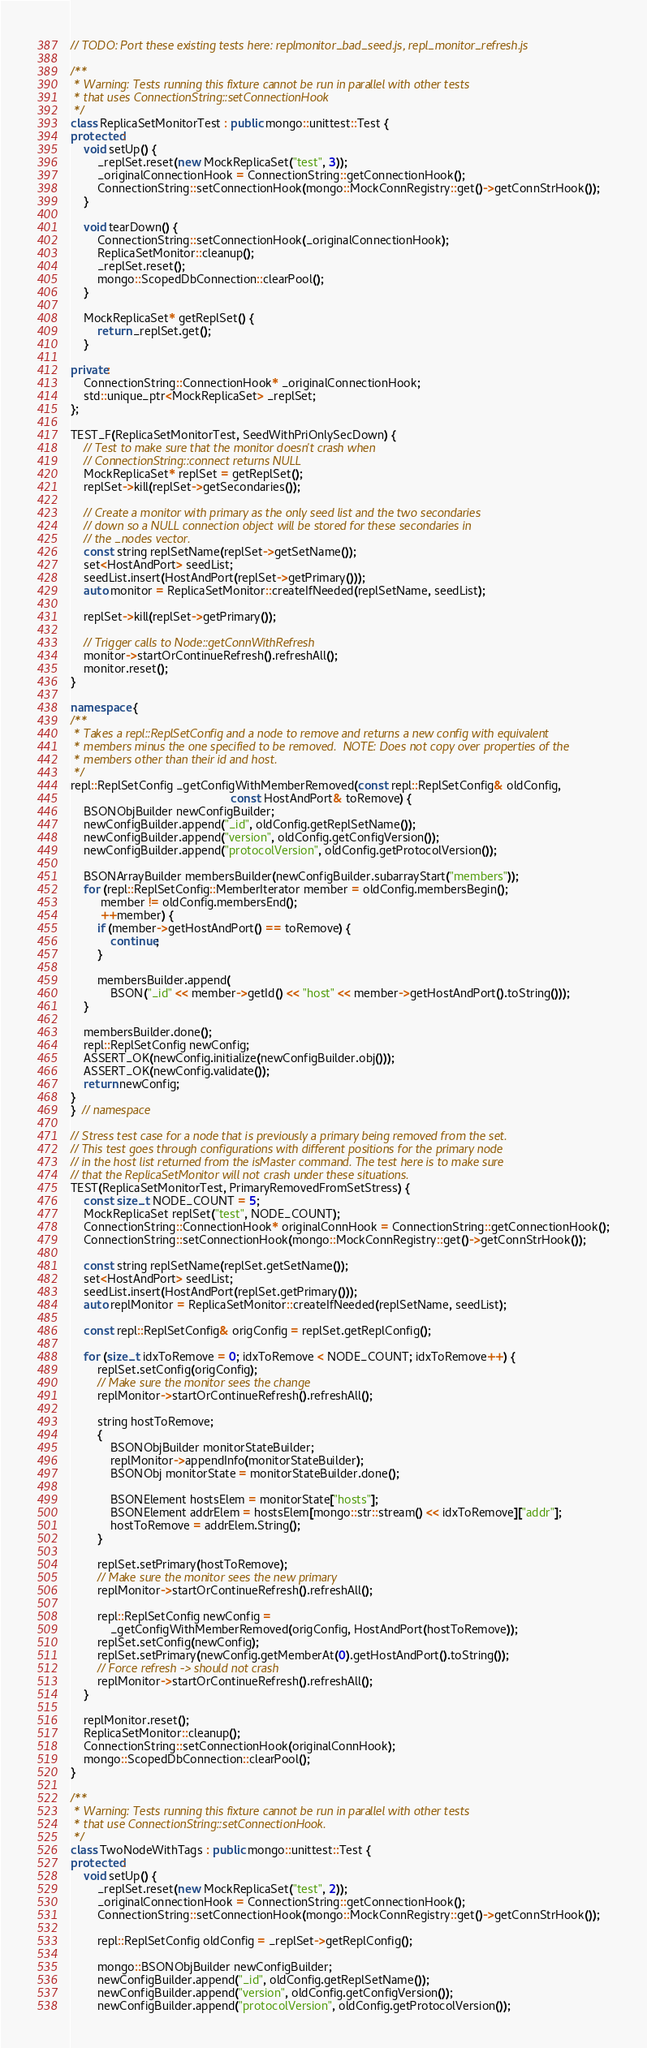<code> <loc_0><loc_0><loc_500><loc_500><_C++_>// TODO: Port these existing tests here: replmonitor_bad_seed.js, repl_monitor_refresh.js

/**
 * Warning: Tests running this fixture cannot be run in parallel with other tests
 * that uses ConnectionString::setConnectionHook
 */
class ReplicaSetMonitorTest : public mongo::unittest::Test {
protected:
    void setUp() {
        _replSet.reset(new MockReplicaSet("test", 3));
        _originalConnectionHook = ConnectionString::getConnectionHook();
        ConnectionString::setConnectionHook(mongo::MockConnRegistry::get()->getConnStrHook());
    }

    void tearDown() {
        ConnectionString::setConnectionHook(_originalConnectionHook);
        ReplicaSetMonitor::cleanup();
        _replSet.reset();
        mongo::ScopedDbConnection::clearPool();
    }

    MockReplicaSet* getReplSet() {
        return _replSet.get();
    }

private:
    ConnectionString::ConnectionHook* _originalConnectionHook;
    std::unique_ptr<MockReplicaSet> _replSet;
};

TEST_F(ReplicaSetMonitorTest, SeedWithPriOnlySecDown) {
    // Test to make sure that the monitor doesn't crash when
    // ConnectionString::connect returns NULL
    MockReplicaSet* replSet = getReplSet();
    replSet->kill(replSet->getSecondaries());

    // Create a monitor with primary as the only seed list and the two secondaries
    // down so a NULL connection object will be stored for these secondaries in
    // the _nodes vector.
    const string replSetName(replSet->getSetName());
    set<HostAndPort> seedList;
    seedList.insert(HostAndPort(replSet->getPrimary()));
    auto monitor = ReplicaSetMonitor::createIfNeeded(replSetName, seedList);

    replSet->kill(replSet->getPrimary());

    // Trigger calls to Node::getConnWithRefresh
    monitor->startOrContinueRefresh().refreshAll();
    monitor.reset();
}

namespace {
/**
 * Takes a repl::ReplSetConfig and a node to remove and returns a new config with equivalent
 * members minus the one specified to be removed.  NOTE: Does not copy over properties of the
 * members other than their id and host.
 */
repl::ReplSetConfig _getConfigWithMemberRemoved(const repl::ReplSetConfig& oldConfig,
                                                const HostAndPort& toRemove) {
    BSONObjBuilder newConfigBuilder;
    newConfigBuilder.append("_id", oldConfig.getReplSetName());
    newConfigBuilder.append("version", oldConfig.getConfigVersion());
    newConfigBuilder.append("protocolVersion", oldConfig.getProtocolVersion());

    BSONArrayBuilder membersBuilder(newConfigBuilder.subarrayStart("members"));
    for (repl::ReplSetConfig::MemberIterator member = oldConfig.membersBegin();
         member != oldConfig.membersEnd();
         ++member) {
        if (member->getHostAndPort() == toRemove) {
            continue;
        }

        membersBuilder.append(
            BSON("_id" << member->getId() << "host" << member->getHostAndPort().toString()));
    }

    membersBuilder.done();
    repl::ReplSetConfig newConfig;
    ASSERT_OK(newConfig.initialize(newConfigBuilder.obj()));
    ASSERT_OK(newConfig.validate());
    return newConfig;
}
}  // namespace

// Stress test case for a node that is previously a primary being removed from the set.
// This test goes through configurations with different positions for the primary node
// in the host list returned from the isMaster command. The test here is to make sure
// that the ReplicaSetMonitor will not crash under these situations.
TEST(ReplicaSetMonitorTest, PrimaryRemovedFromSetStress) {
    const size_t NODE_COUNT = 5;
    MockReplicaSet replSet("test", NODE_COUNT);
    ConnectionString::ConnectionHook* originalConnHook = ConnectionString::getConnectionHook();
    ConnectionString::setConnectionHook(mongo::MockConnRegistry::get()->getConnStrHook());

    const string replSetName(replSet.getSetName());
    set<HostAndPort> seedList;
    seedList.insert(HostAndPort(replSet.getPrimary()));
    auto replMonitor = ReplicaSetMonitor::createIfNeeded(replSetName, seedList);

    const repl::ReplSetConfig& origConfig = replSet.getReplConfig();

    for (size_t idxToRemove = 0; idxToRemove < NODE_COUNT; idxToRemove++) {
        replSet.setConfig(origConfig);
        // Make sure the monitor sees the change
        replMonitor->startOrContinueRefresh().refreshAll();

        string hostToRemove;
        {
            BSONObjBuilder monitorStateBuilder;
            replMonitor->appendInfo(monitorStateBuilder);
            BSONObj monitorState = monitorStateBuilder.done();

            BSONElement hostsElem = monitorState["hosts"];
            BSONElement addrElem = hostsElem[mongo::str::stream() << idxToRemove]["addr"];
            hostToRemove = addrElem.String();
        }

        replSet.setPrimary(hostToRemove);
        // Make sure the monitor sees the new primary
        replMonitor->startOrContinueRefresh().refreshAll();

        repl::ReplSetConfig newConfig =
            _getConfigWithMemberRemoved(origConfig, HostAndPort(hostToRemove));
        replSet.setConfig(newConfig);
        replSet.setPrimary(newConfig.getMemberAt(0).getHostAndPort().toString());
        // Force refresh -> should not crash
        replMonitor->startOrContinueRefresh().refreshAll();
    }

    replMonitor.reset();
    ReplicaSetMonitor::cleanup();
    ConnectionString::setConnectionHook(originalConnHook);
    mongo::ScopedDbConnection::clearPool();
}

/**
 * Warning: Tests running this fixture cannot be run in parallel with other tests
 * that use ConnectionString::setConnectionHook.
 */
class TwoNodeWithTags : public mongo::unittest::Test {
protected:
    void setUp() {
        _replSet.reset(new MockReplicaSet("test", 2));
        _originalConnectionHook = ConnectionString::getConnectionHook();
        ConnectionString::setConnectionHook(mongo::MockConnRegistry::get()->getConnStrHook());

        repl::ReplSetConfig oldConfig = _replSet->getReplConfig();

        mongo::BSONObjBuilder newConfigBuilder;
        newConfigBuilder.append("_id", oldConfig.getReplSetName());
        newConfigBuilder.append("version", oldConfig.getConfigVersion());
        newConfigBuilder.append("protocolVersion", oldConfig.getProtocolVersion());
</code> 